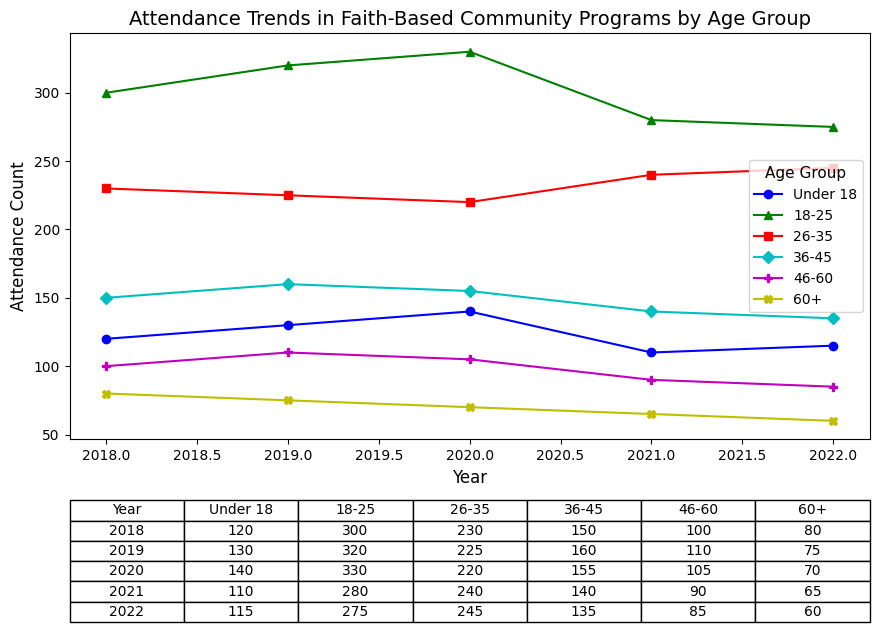What was the attendance trend for the 18-25 age group from 2018 to 2022? The plot shows the attendance counts for the 18-25 age group over the years 2018 to 2022. In 2018, the attendance count was 300. It increased to 320 in 2019 and again to 330 in 2020, but then dropped to 280 in 2021, and further to 275 in 2022.
Answer: Increased from 2018 to 2020, then decreased in 2021 and 2022 Which age group had the highest attendance in 2020? By observing the plot, we can identify which age group had the highest attendance in 2020 by comparing the height of the markers or lines. The 18-25 age group had the highest attendance in 2020 with a count of 330.
Answer: 18-25 How did the attendance count for the 46-60 age group change from 2018 to 2022? The attendance for the 46-60 age group in 2018 was 100. It increased to 110 in 2019, decreased to 105 in 2020, further decreased to 90 in 2021, and then to 85 in 2022. This indicates an overall decline in attendance over the years.
Answer: Decreased overall What is the average attendance for the 36-45 age group across all years? To calculate the average, sum the attendance counts from 2018 to 2022 and divide by the total number of years. (150 + 160 + 155 + 140 + 135) / 5 = 740 / 5 = 148
Answer: 148 Which age group showed the most consistent attendance count over the years? By examining the plot, we look for the age group with the least fluctuation between years. The 26-35 age group shows relatively small changes, with attendance counts close to each other (230, 225, 220, 240, 245).
Answer: 26-35 Compare the attendance trends between the Under 18 and 60+ age groups from 2018 to 2022. The Under 18 age group had an increase from 120 in 2018 to 140 in 2020, followed by a decrease to 115 in 2022. The 60+ age group consistently declined from 80 in 2018 to 60 in 2022. While the Under 18 group had both rises and falls, the 60+ group had a continuous decline.
Answer: Under 18 fluctuated; 60+ declined What was the difference in attendance between the 18-25 and 46-60 age groups in 2019? In 2019, the attendance counts were 320 for the 18-25 age group and 110 for the 46-60 age group. Subtracting these gives 320 - 110 = 210.
Answer: 210 Did any age group have a peak attendance year that significantly stands out? The plot indicates that the 18-25 age group peaked in 2020 with an attendance count of 330, which is higher than its counts in other years and the highest among all age groups in 2020.
Answer: 18-25 in 2020 For the Under 18 age group, what was the net change in attendance from 2018 to 2022? The attendance in 2018 was 120, and in 2022 it was 115. The net change is 115 - 120 = -5.
Answer: -5 Which age group had the lowest attendance in 2018? Looking at the chart, the 60+ age group had the lowest attendance in 2018 with a count of 80.
Answer: 60+ 